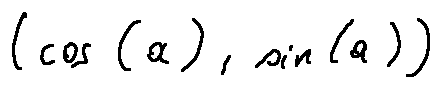Convert formula to latex. <formula><loc_0><loc_0><loc_500><loc_500>( \cos ( a ) , \sin ( a ) )</formula> 